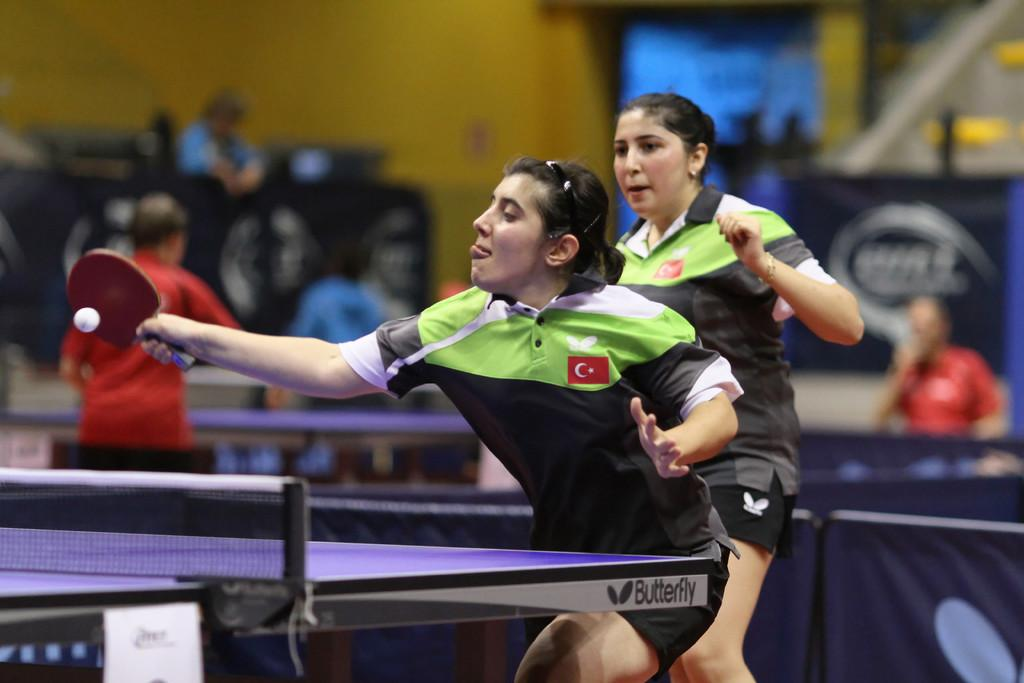What sport are the two women playing in the image? The two women are playing table tennis in the image. What is the woman with the bat doing? The woman with the bat is hitting the ball. Are there any other people present in the image? Yes, there are people standing behind the women playing table tennis. What type of back support is the table tennis player using in the image? There is no indication of any back support being used in the image; the focus is on the women playing table tennis and their actions. 